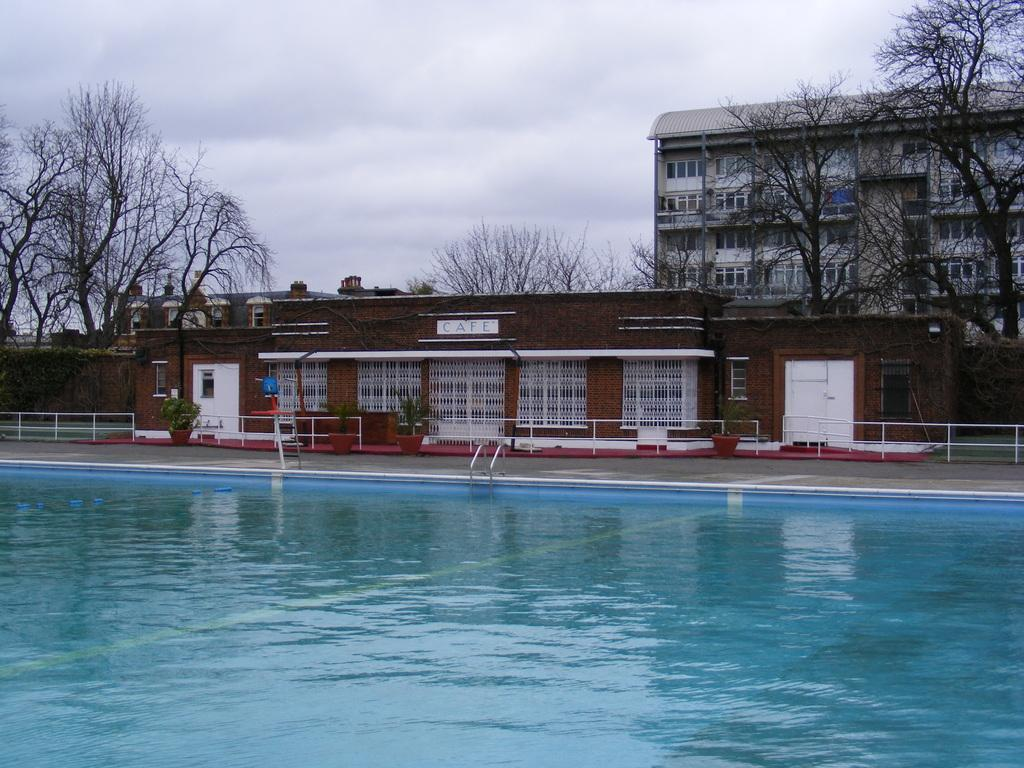What type of natural elements can be seen in the image? There are trees in the image. What type of man-made structures are present in the image? There are buildings in the image. What object is located at the bottom of the image? There is a pole at the bottom of the image. What is visible at the top of the image? The sky is visible at the top of the image. What type of jewel is hanging from the tree in the image? There is no jewel hanging from the tree in the image; only trees, buildings, a pole, and the sky are present. What type of joke is being told by the buildings in the image? There is no joke being told by the buildings in the image; they are stationary structures. 